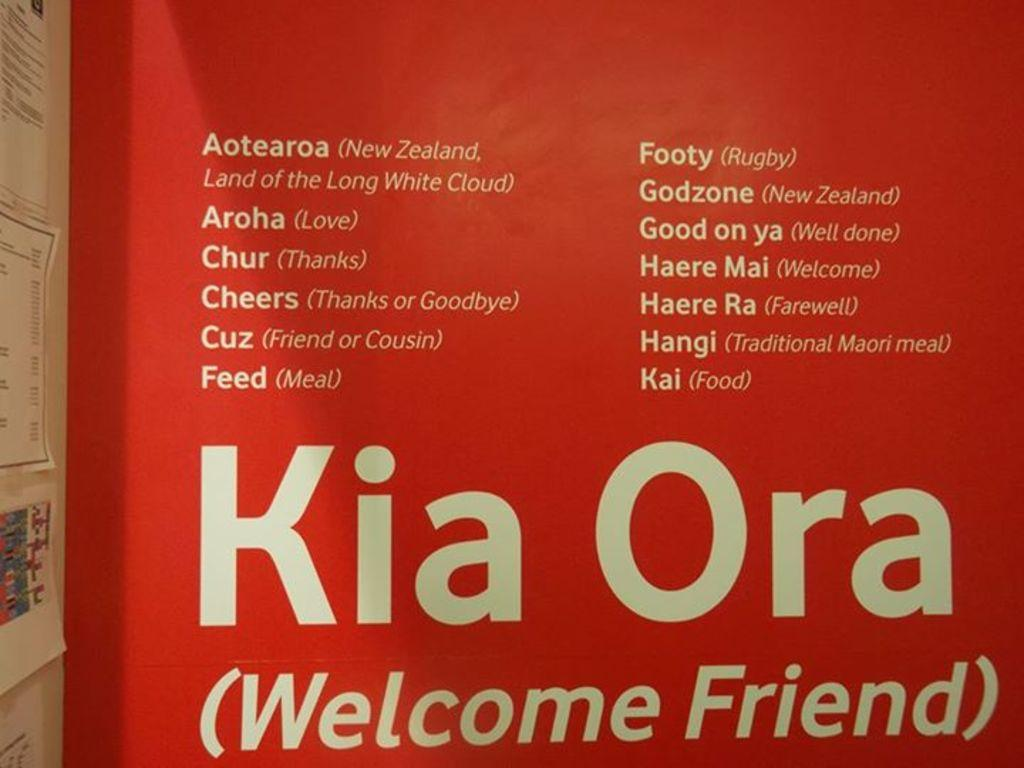<image>
Describe the image concisely. Kia Ora (Welcom Friend) sign on a rad background 